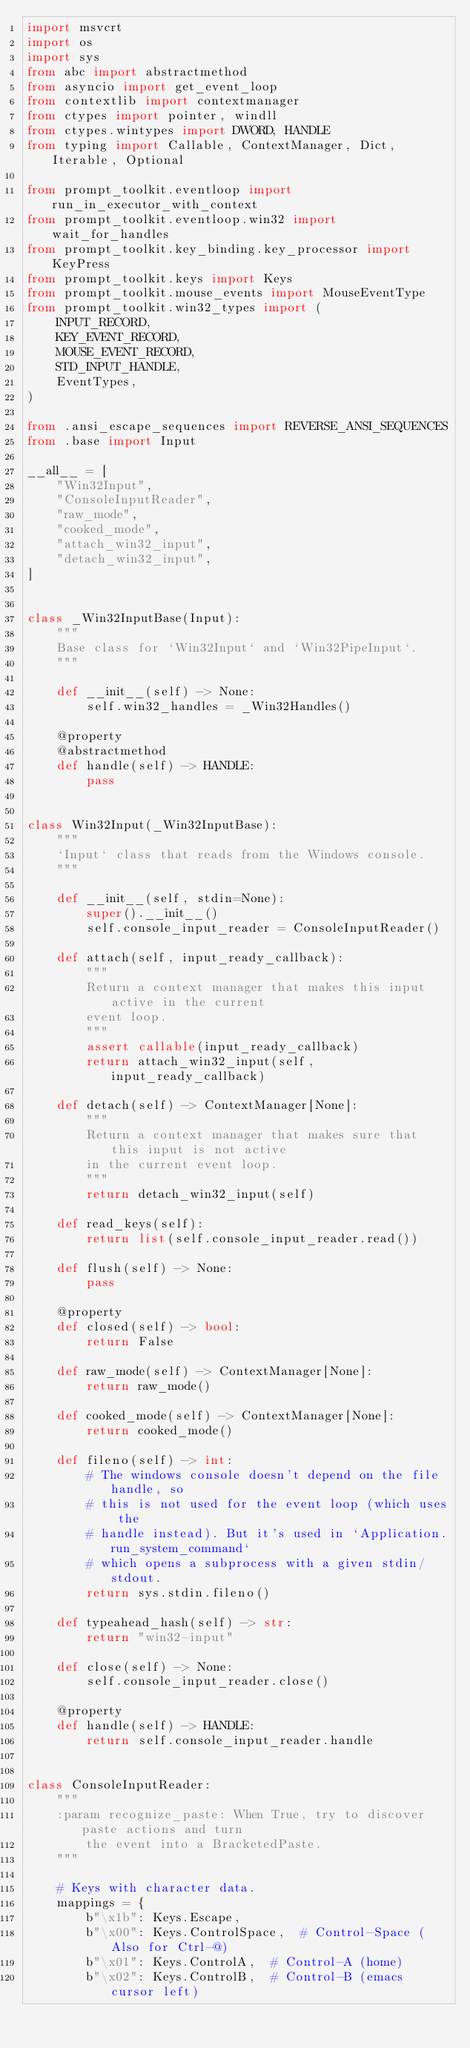<code> <loc_0><loc_0><loc_500><loc_500><_Python_>import msvcrt
import os
import sys
from abc import abstractmethod
from asyncio import get_event_loop
from contextlib import contextmanager
from ctypes import pointer, windll
from ctypes.wintypes import DWORD, HANDLE
from typing import Callable, ContextManager, Dict, Iterable, Optional

from prompt_toolkit.eventloop import run_in_executor_with_context
from prompt_toolkit.eventloop.win32 import wait_for_handles
from prompt_toolkit.key_binding.key_processor import KeyPress
from prompt_toolkit.keys import Keys
from prompt_toolkit.mouse_events import MouseEventType
from prompt_toolkit.win32_types import (
    INPUT_RECORD,
    KEY_EVENT_RECORD,
    MOUSE_EVENT_RECORD,
    STD_INPUT_HANDLE,
    EventTypes,
)

from .ansi_escape_sequences import REVERSE_ANSI_SEQUENCES
from .base import Input

__all__ = [
    "Win32Input",
    "ConsoleInputReader",
    "raw_mode",
    "cooked_mode",
    "attach_win32_input",
    "detach_win32_input",
]


class _Win32InputBase(Input):
    """
    Base class for `Win32Input` and `Win32PipeInput`.
    """

    def __init__(self) -> None:
        self.win32_handles = _Win32Handles()

    @property
    @abstractmethod
    def handle(self) -> HANDLE:
        pass


class Win32Input(_Win32InputBase):
    """
    `Input` class that reads from the Windows console.
    """

    def __init__(self, stdin=None):
        super().__init__()
        self.console_input_reader = ConsoleInputReader()

    def attach(self, input_ready_callback):
        """
        Return a context manager that makes this input active in the current
        event loop.
        """
        assert callable(input_ready_callback)
        return attach_win32_input(self, input_ready_callback)

    def detach(self) -> ContextManager[None]:
        """
        Return a context manager that makes sure that this input is not active
        in the current event loop.
        """
        return detach_win32_input(self)

    def read_keys(self):
        return list(self.console_input_reader.read())

    def flush(self) -> None:
        pass

    @property
    def closed(self) -> bool:
        return False

    def raw_mode(self) -> ContextManager[None]:
        return raw_mode()

    def cooked_mode(self) -> ContextManager[None]:
        return cooked_mode()

    def fileno(self) -> int:
        # The windows console doesn't depend on the file handle, so
        # this is not used for the event loop (which uses the
        # handle instead). But it's used in `Application.run_system_command`
        # which opens a subprocess with a given stdin/stdout.
        return sys.stdin.fileno()

    def typeahead_hash(self) -> str:
        return "win32-input"

    def close(self) -> None:
        self.console_input_reader.close()

    @property
    def handle(self) -> HANDLE:
        return self.console_input_reader.handle


class ConsoleInputReader:
    """
    :param recognize_paste: When True, try to discover paste actions and turn
        the event into a BracketedPaste.
    """

    # Keys with character data.
    mappings = {
        b"\x1b": Keys.Escape,
        b"\x00": Keys.ControlSpace,  # Control-Space (Also for Ctrl-@)
        b"\x01": Keys.ControlA,  # Control-A (home)
        b"\x02": Keys.ControlB,  # Control-B (emacs cursor left)</code> 